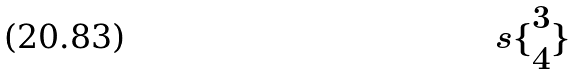Convert formula to latex. <formula><loc_0><loc_0><loc_500><loc_500>s \{ \begin{matrix} 3 \\ 4 \end{matrix} \}</formula> 